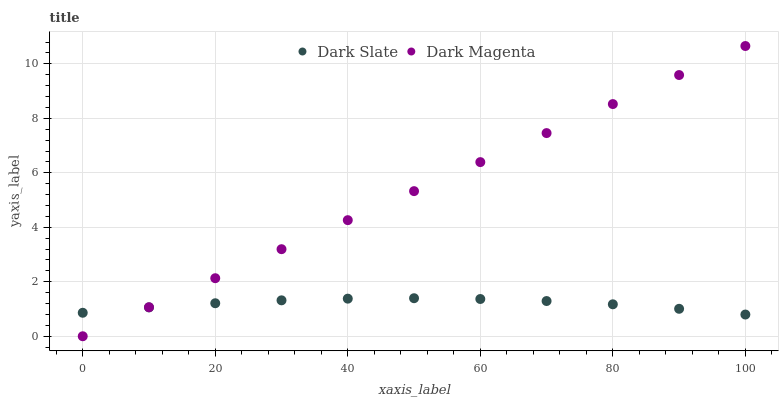Does Dark Slate have the minimum area under the curve?
Answer yes or no. Yes. Does Dark Magenta have the maximum area under the curve?
Answer yes or no. Yes. Does Dark Magenta have the minimum area under the curve?
Answer yes or no. No. Is Dark Magenta the smoothest?
Answer yes or no. Yes. Is Dark Slate the roughest?
Answer yes or no. Yes. Is Dark Magenta the roughest?
Answer yes or no. No. Does Dark Magenta have the lowest value?
Answer yes or no. Yes. Does Dark Magenta have the highest value?
Answer yes or no. Yes. Does Dark Slate intersect Dark Magenta?
Answer yes or no. Yes. Is Dark Slate less than Dark Magenta?
Answer yes or no. No. Is Dark Slate greater than Dark Magenta?
Answer yes or no. No. 